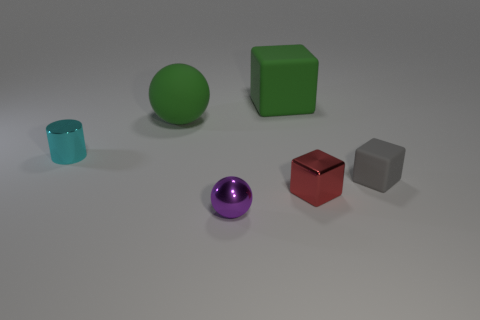Subtract 1 blocks. How many blocks are left? 2 Subtract all big green cubes. How many cubes are left? 2 Add 3 purple metal spheres. How many objects exist? 9 Subtract all spheres. How many objects are left? 4 Subtract all yellow blocks. Subtract all blue cylinders. How many blocks are left? 3 Add 2 large red matte blocks. How many large red matte blocks exist? 2 Subtract 1 gray cubes. How many objects are left? 5 Subtract all blue rubber cylinders. Subtract all tiny purple metal spheres. How many objects are left? 5 Add 3 green matte cubes. How many green matte cubes are left? 4 